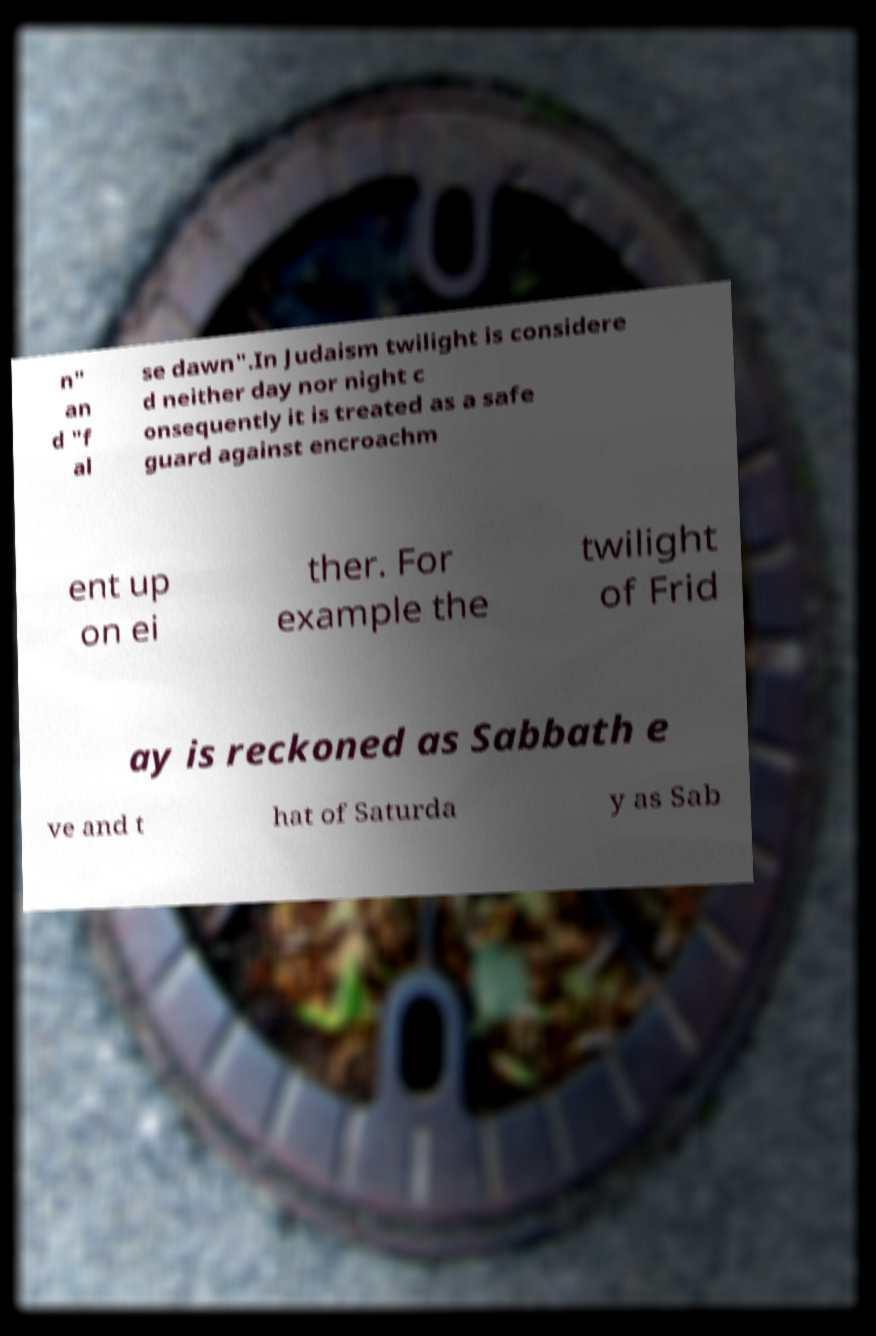Can you accurately transcribe the text from the provided image for me? n" an d "f al se dawn".In Judaism twilight is considere d neither day nor night c onsequently it is treated as a safe guard against encroachm ent up on ei ther. For example the twilight of Frid ay is reckoned as Sabbath e ve and t hat of Saturda y as Sab 